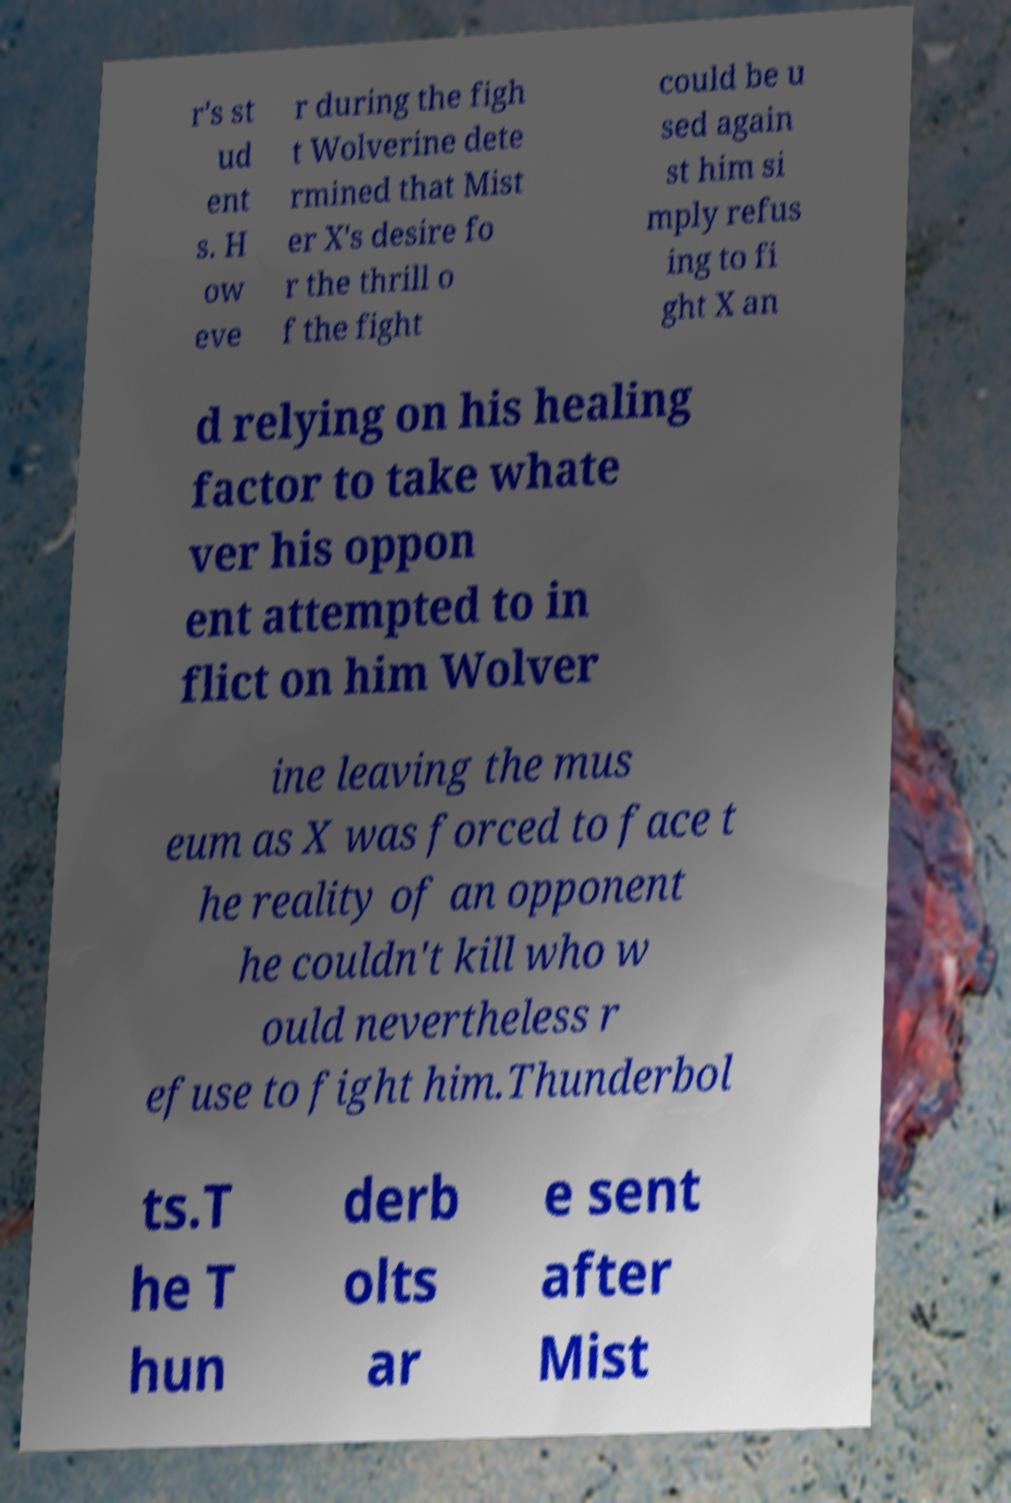Please identify and transcribe the text found in this image. r's st ud ent s. H ow eve r during the figh t Wolverine dete rmined that Mist er X's desire fo r the thrill o f the fight could be u sed again st him si mply refus ing to fi ght X an d relying on his healing factor to take whate ver his oppon ent attempted to in flict on him Wolver ine leaving the mus eum as X was forced to face t he reality of an opponent he couldn't kill who w ould nevertheless r efuse to fight him.Thunderbol ts.T he T hun derb olts ar e sent after Mist 